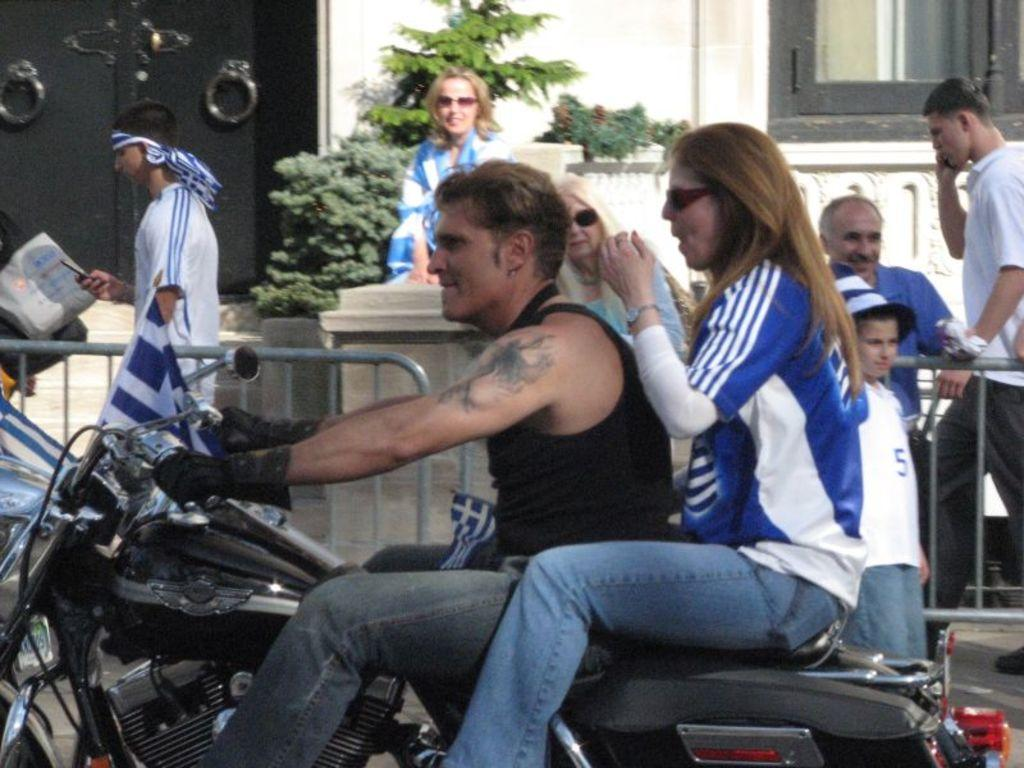What is the main subject of the image? The main subject of the image is a person riding a bike. What is the person wearing? The person is wearing black jeans. Can you describe the other individuals in the image? There is a woman behind the person riding the bike, and a group of people beside them. What type of zipper can be seen on the can in the image? There is no can present in the image, so it is not possible to determine if there is a zipper on it. 